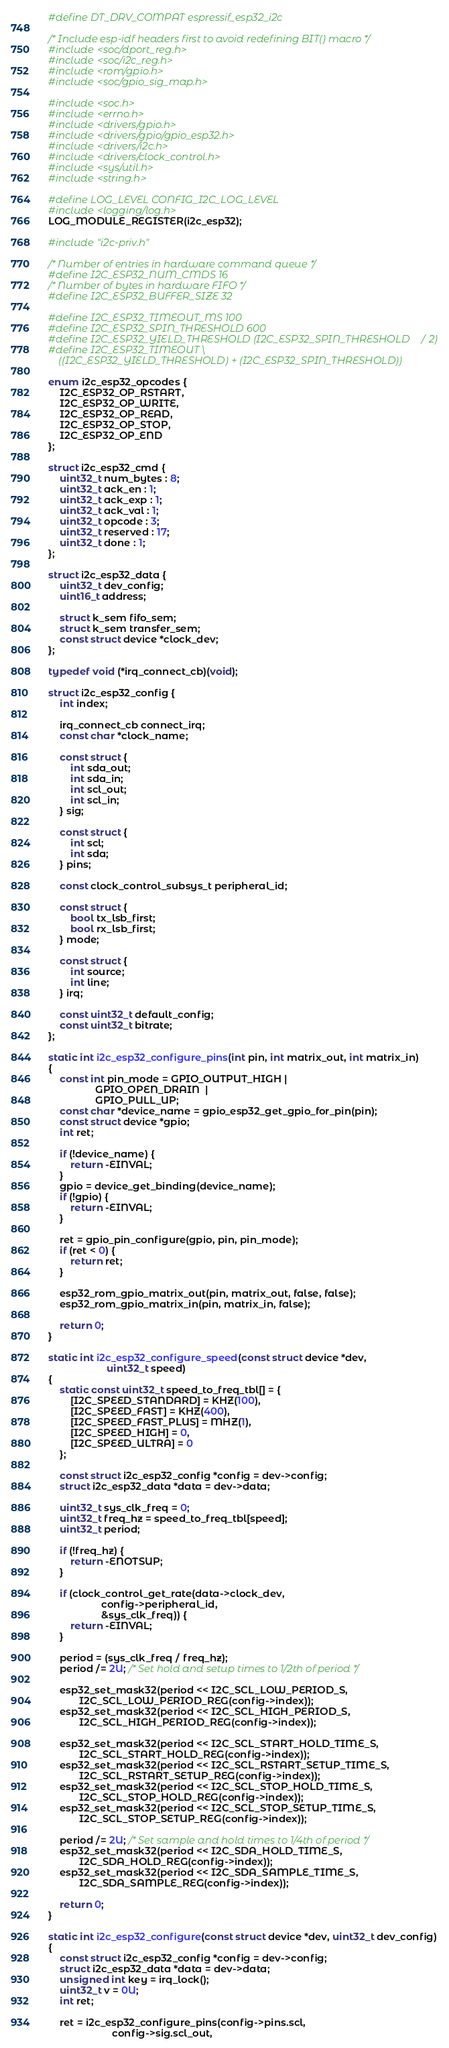Convert code to text. <code><loc_0><loc_0><loc_500><loc_500><_C_>#define DT_DRV_COMPAT espressif_esp32_i2c

/* Include esp-idf headers first to avoid redefining BIT() macro */
#include <soc/dport_reg.h>
#include <soc/i2c_reg.h>
#include <rom/gpio.h>
#include <soc/gpio_sig_map.h>

#include <soc.h>
#include <errno.h>
#include <drivers/gpio.h>
#include <drivers/gpio/gpio_esp32.h>
#include <drivers/i2c.h>
#include <drivers/clock_control.h>
#include <sys/util.h>
#include <string.h>

#define LOG_LEVEL CONFIG_I2C_LOG_LEVEL
#include <logging/log.h>
LOG_MODULE_REGISTER(i2c_esp32);

#include "i2c-priv.h"

/* Number of entries in hardware command queue */
#define I2C_ESP32_NUM_CMDS 16
/* Number of bytes in hardware FIFO */
#define I2C_ESP32_BUFFER_SIZE 32

#define I2C_ESP32_TIMEOUT_MS 100
#define I2C_ESP32_SPIN_THRESHOLD 600
#define I2C_ESP32_YIELD_THRESHOLD (I2C_ESP32_SPIN_THRESHOLD / 2)
#define I2C_ESP32_TIMEOUT \
	((I2C_ESP32_YIELD_THRESHOLD) + (I2C_ESP32_SPIN_THRESHOLD))

enum i2c_esp32_opcodes {
	I2C_ESP32_OP_RSTART,
	I2C_ESP32_OP_WRITE,
	I2C_ESP32_OP_READ,
	I2C_ESP32_OP_STOP,
	I2C_ESP32_OP_END
};

struct i2c_esp32_cmd {
	uint32_t num_bytes : 8;
	uint32_t ack_en : 1;
	uint32_t ack_exp : 1;
	uint32_t ack_val : 1;
	uint32_t opcode : 3;
	uint32_t reserved : 17;
	uint32_t done : 1;
};

struct i2c_esp32_data {
	uint32_t dev_config;
	uint16_t address;

	struct k_sem fifo_sem;
	struct k_sem transfer_sem;
	const struct device *clock_dev;
};

typedef void (*irq_connect_cb)(void);

struct i2c_esp32_config {
	int index;

	irq_connect_cb connect_irq;
	const char *clock_name;

	const struct {
		int sda_out;
		int sda_in;
		int scl_out;
		int scl_in;
	} sig;

	const struct {
		int scl;
		int sda;
	} pins;

	const clock_control_subsys_t peripheral_id;

	const struct {
		bool tx_lsb_first;
		bool rx_lsb_first;
	} mode;

	const struct {
		int source;
		int line;
	} irq;

	const uint32_t default_config;
	const uint32_t bitrate;
};

static int i2c_esp32_configure_pins(int pin, int matrix_out, int matrix_in)
{
	const int pin_mode = GPIO_OUTPUT_HIGH |
			     GPIO_OPEN_DRAIN  |
			     GPIO_PULL_UP;
	const char *device_name = gpio_esp32_get_gpio_for_pin(pin);
	const struct device *gpio;
	int ret;

	if (!device_name) {
		return -EINVAL;
	}
	gpio = device_get_binding(device_name);
	if (!gpio) {
		return -EINVAL;
	}

	ret = gpio_pin_configure(gpio, pin, pin_mode);
	if (ret < 0) {
		return ret;
	}

	esp32_rom_gpio_matrix_out(pin, matrix_out, false, false);
	esp32_rom_gpio_matrix_in(pin, matrix_in, false);

	return 0;
}

static int i2c_esp32_configure_speed(const struct device *dev,
				     uint32_t speed)
{
	static const uint32_t speed_to_freq_tbl[] = {
		[I2C_SPEED_STANDARD] = KHZ(100),
		[I2C_SPEED_FAST] = KHZ(400),
		[I2C_SPEED_FAST_PLUS] = MHZ(1),
		[I2C_SPEED_HIGH] = 0,
		[I2C_SPEED_ULTRA] = 0
	};

	const struct i2c_esp32_config *config = dev->config;
	struct i2c_esp32_data *data = dev->data;

	uint32_t sys_clk_freq = 0;
	uint32_t freq_hz = speed_to_freq_tbl[speed];
	uint32_t period;

	if (!freq_hz) {
		return -ENOTSUP;
	}

	if (clock_control_get_rate(data->clock_dev,
				   config->peripheral_id,
				   &sys_clk_freq)) {
		return -EINVAL;
	}

	period = (sys_clk_freq / freq_hz);
	period /= 2U; /* Set hold and setup times to 1/2th of period */

	esp32_set_mask32(period << I2C_SCL_LOW_PERIOD_S,
		   I2C_SCL_LOW_PERIOD_REG(config->index));
	esp32_set_mask32(period << I2C_SCL_HIGH_PERIOD_S,
		   I2C_SCL_HIGH_PERIOD_REG(config->index));

	esp32_set_mask32(period << I2C_SCL_START_HOLD_TIME_S,
		   I2C_SCL_START_HOLD_REG(config->index));
	esp32_set_mask32(period << I2C_SCL_RSTART_SETUP_TIME_S,
		   I2C_SCL_RSTART_SETUP_REG(config->index));
	esp32_set_mask32(period << I2C_SCL_STOP_HOLD_TIME_S,
		   I2C_SCL_STOP_HOLD_REG(config->index));
	esp32_set_mask32(period << I2C_SCL_STOP_SETUP_TIME_S,
		   I2C_SCL_STOP_SETUP_REG(config->index));

	period /= 2U; /* Set sample and hold times to 1/4th of period */
	esp32_set_mask32(period << I2C_SDA_HOLD_TIME_S,
		   I2C_SDA_HOLD_REG(config->index));
	esp32_set_mask32(period << I2C_SDA_SAMPLE_TIME_S,
		   I2C_SDA_SAMPLE_REG(config->index));

	return 0;
}

static int i2c_esp32_configure(const struct device *dev, uint32_t dev_config)
{
	const struct i2c_esp32_config *config = dev->config;
	struct i2c_esp32_data *data = dev->data;
	unsigned int key = irq_lock();
	uint32_t v = 0U;
	int ret;

	ret = i2c_esp32_configure_pins(config->pins.scl,
				       config->sig.scl_out,</code> 